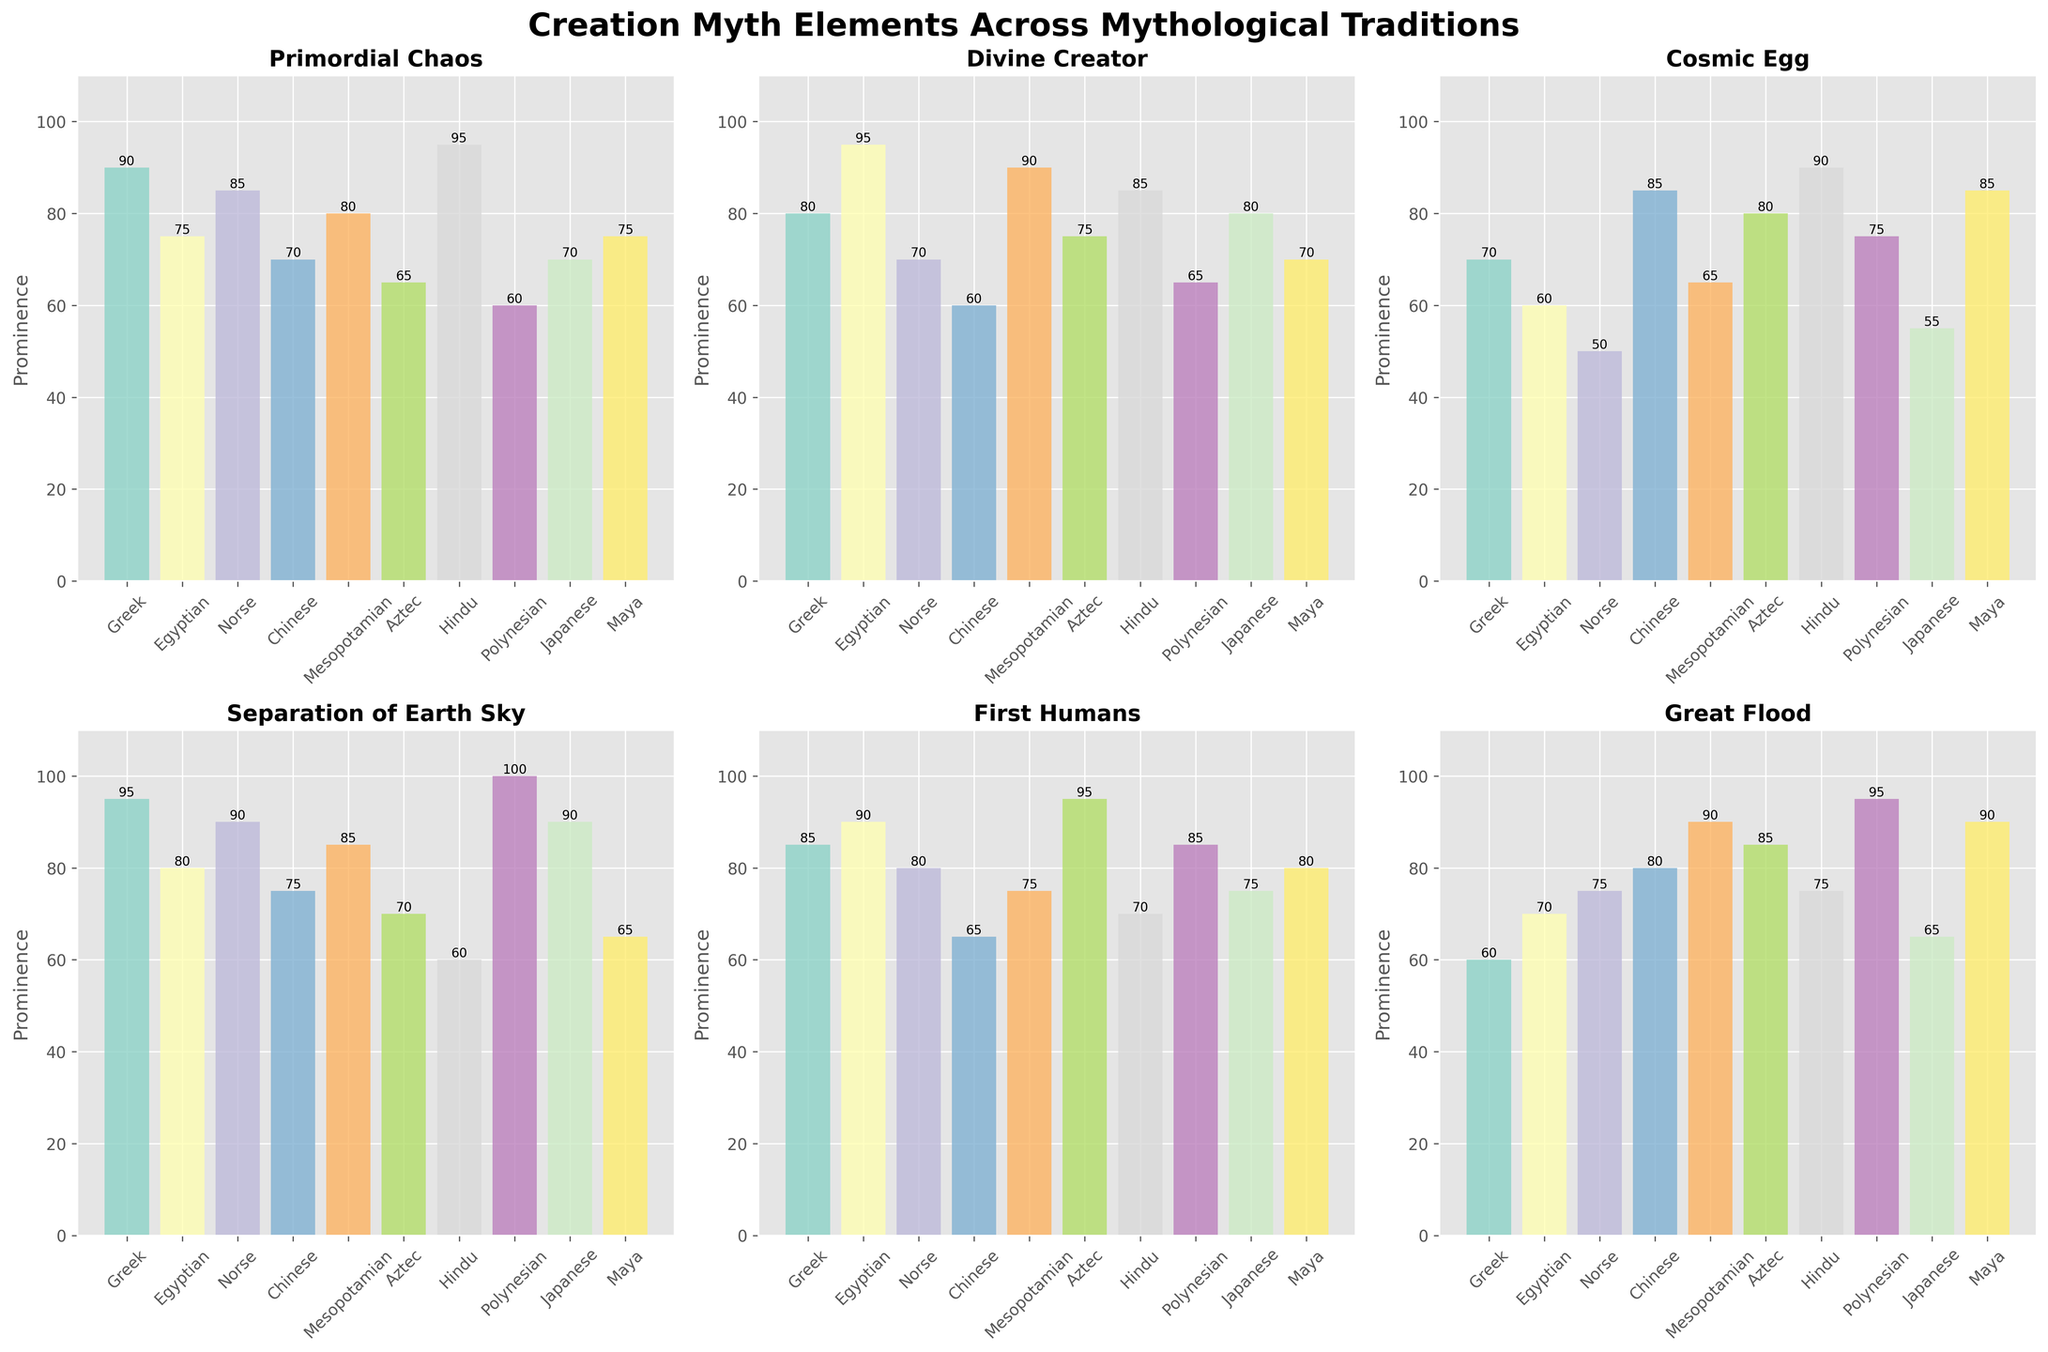What is the title of the figure? The title is displayed at the top of the figure in bold text.
Answer: Creation Myth Elements Across Mythological Traditions Which tradition has the highest prominence for the Primordial Chaos element? By looking at the Primordial Chaos subplot, the tallest bar is for Hindu, indicating the highest prominence.
Answer: Hindu Which two elements have a prominence of exactly 90 in both the Greek and Mesopotamian traditions? In the subplots for both Greek and Mesopotamian traditions, check bars with a height of 90. These elements are Primordial Chaos for both traditions.
Answer: Primordial Chaos What is the average prominence of the Divine Creator element across all traditions? Add up the values from each tradition for Divine Creator (80+95+70+60+90+75+85+65+80+70) and divide by the number of traditions (10). The sum is 770, so the average is 770/10.
Answer: 77 Which tradition has the lowest prominence for the Cosmic Egg element? By examining the Cosmic Egg subplot, the shortest bar corresponds to Norse.
Answer: Norse Compare the prominence of the Great Flood element between Aztec and Polynesian traditions. Which one is higher? Look at the bars in the Great Flood subplot for Aztec and Polynesian. The Polynesian bar (95) is higher than the Aztec bar (85).
Answer: Polynesian Is the prominence of the First Humans element greater than 75 in the Chinese tradition? Check the First Humans subplot bar for Chinese, its height is 65, which is less than 75.
Answer: No How many elements have a prominence greater than 80 in the Japanese tradition? For the Japanese tradition, check each subplot, identifying elements with bars taller than 80. Only the Divine Creator (80) meets this criterion.
Answer: 1 For the Mesopotamian tradition, which element has the second-highest prominence? In the Mesopotamian subplot, the highest value is Great Flood (90). The second-highest bar is Divine Creator, also at 90.
Answer: Divine Creator What are the two elements with the highest prominence in the Greek tradition? In the Greek subplot, the tallest bars are for Separation of Earth and Sky (95) and Primordial Chaos (90), showing these elements have the highest prominence.
Answer: Separation of Earth and Sky, Primordial Chaos How much higher is the prominence of the Separation of Earth and Sky element in the Polynesian tradition compared to the Hindu tradition? In the subplot for Separation of Earth and Sky, the Polynesian value is 100 and the Hindu value is 60. The difference is 100 - 60.
Answer: 40 